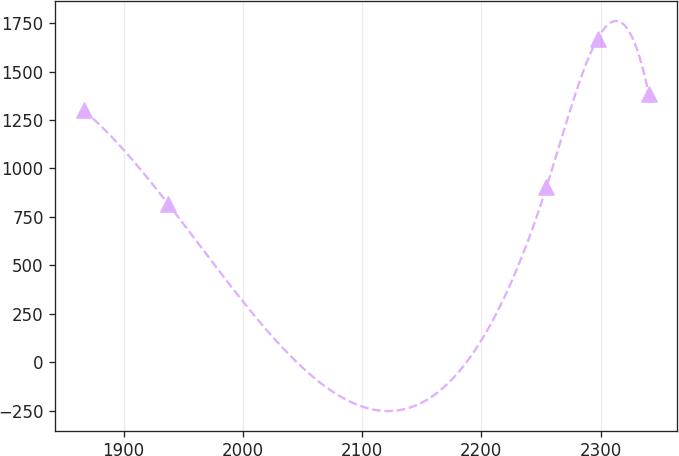Convert chart. <chart><loc_0><loc_0><loc_500><loc_500><line_chart><ecel><fcel>Unnamed: 1<nl><fcel>1866.44<fcel>1300.39<nl><fcel>1937.35<fcel>817.01<nl><fcel>2254.57<fcel>902.3<nl><fcel>2297.47<fcel>1669.95<nl><fcel>2340.36<fcel>1385.68<nl></chart> 